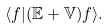<formula> <loc_0><loc_0><loc_500><loc_500>\langle f | ( \mathbb { E } + \mathbb { V } ) f \rangle .</formula> 